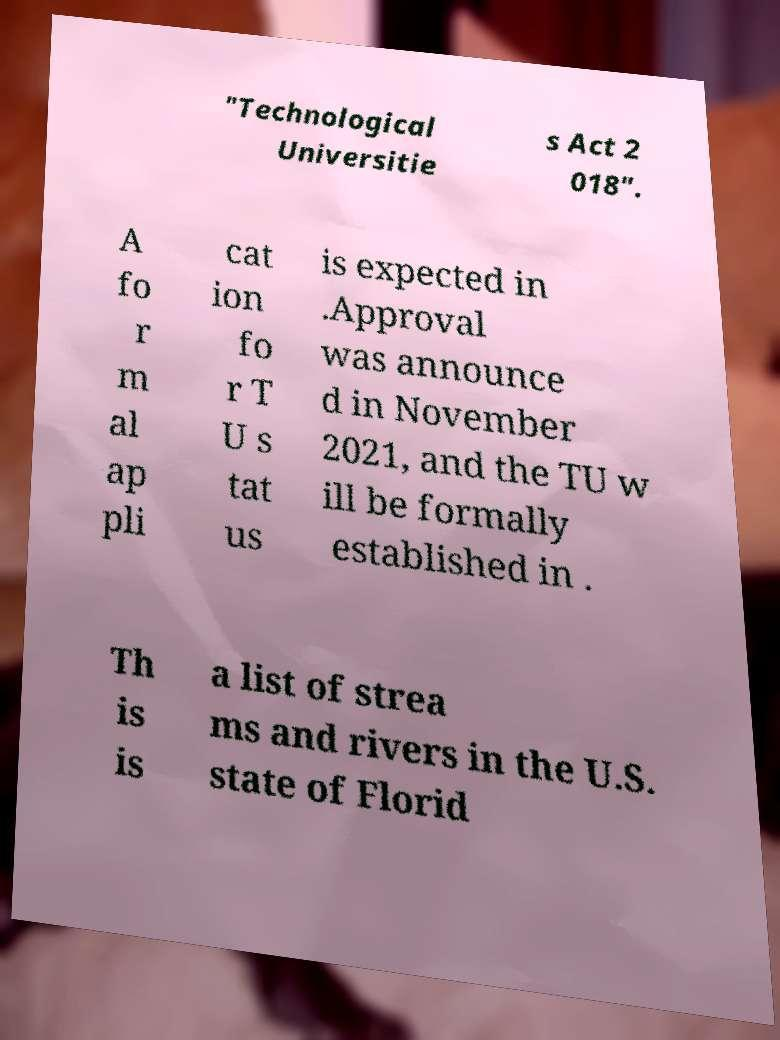Please identify and transcribe the text found in this image. "Technological Universitie s Act 2 018". A fo r m al ap pli cat ion fo r T U s tat us is expected in .Approval was announce d in November 2021, and the TU w ill be formally established in . Th is is a list of strea ms and rivers in the U.S. state of Florid 